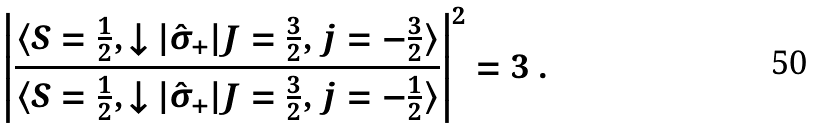<formula> <loc_0><loc_0><loc_500><loc_500>\left | \frac { \langle S = \frac { 1 } { 2 } , \downarrow | \hat { \sigma } _ { + } | J = \frac { 3 } { 2 } , j = - \frac { 3 } { 2 } \rangle } { \langle S = \frac { 1 } { 2 } , \downarrow | \hat { \sigma } _ { + } | J = \frac { 3 } { 2 } , j = - \frac { 1 } { 2 } \rangle } \right | ^ { 2 } = 3 \ .</formula> 